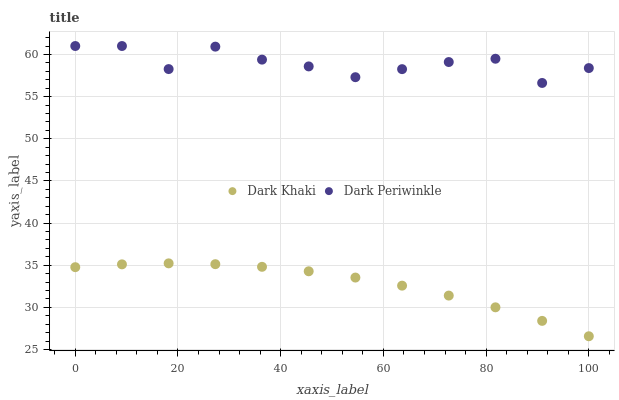Does Dark Khaki have the minimum area under the curve?
Answer yes or no. Yes. Does Dark Periwinkle have the maximum area under the curve?
Answer yes or no. Yes. Does Dark Periwinkle have the minimum area under the curve?
Answer yes or no. No. Is Dark Khaki the smoothest?
Answer yes or no. Yes. Is Dark Periwinkle the roughest?
Answer yes or no. Yes. Is Dark Periwinkle the smoothest?
Answer yes or no. No. Does Dark Khaki have the lowest value?
Answer yes or no. Yes. Does Dark Periwinkle have the lowest value?
Answer yes or no. No. Does Dark Periwinkle have the highest value?
Answer yes or no. Yes. Is Dark Khaki less than Dark Periwinkle?
Answer yes or no. Yes. Is Dark Periwinkle greater than Dark Khaki?
Answer yes or no. Yes. Does Dark Khaki intersect Dark Periwinkle?
Answer yes or no. No. 